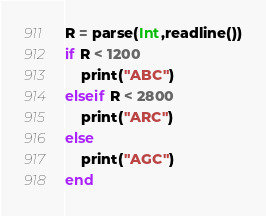Convert code to text. <code><loc_0><loc_0><loc_500><loc_500><_Julia_>R = parse(Int,readline())
if R < 1200
    print("ABC")
elseif R < 2800
    print("ARC")
else
    print("AGC")
end
</code> 